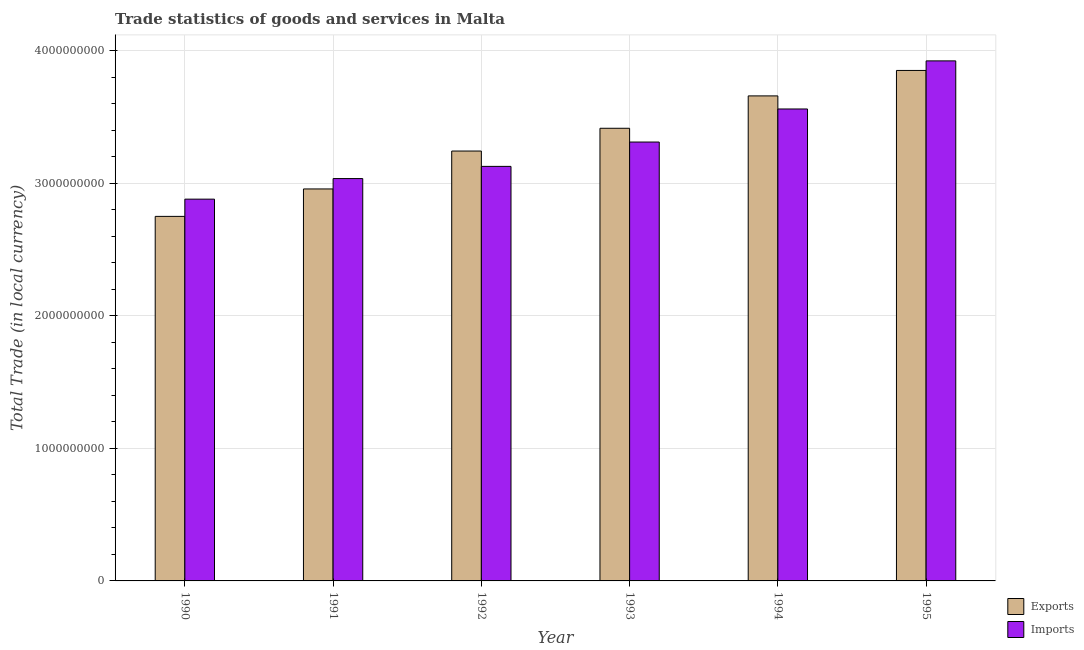How many different coloured bars are there?
Your answer should be compact. 2. How many groups of bars are there?
Your response must be concise. 6. How many bars are there on the 5th tick from the left?
Offer a very short reply. 2. How many bars are there on the 6th tick from the right?
Make the answer very short. 2. What is the label of the 6th group of bars from the left?
Offer a terse response. 1995. What is the export of goods and services in 1992?
Your answer should be very brief. 3.24e+09. Across all years, what is the maximum export of goods and services?
Keep it short and to the point. 3.85e+09. Across all years, what is the minimum imports of goods and services?
Your response must be concise. 2.88e+09. In which year was the export of goods and services minimum?
Keep it short and to the point. 1990. What is the total imports of goods and services in the graph?
Offer a very short reply. 1.98e+1. What is the difference between the export of goods and services in 1990 and that in 1992?
Ensure brevity in your answer.  -4.93e+08. What is the difference between the export of goods and services in 1992 and the imports of goods and services in 1993?
Your answer should be compact. -1.72e+08. What is the average export of goods and services per year?
Provide a short and direct response. 3.31e+09. In how many years, is the imports of goods and services greater than 200000000 LCU?
Give a very brief answer. 6. What is the ratio of the imports of goods and services in 1992 to that in 1994?
Keep it short and to the point. 0.88. What is the difference between the highest and the second highest imports of goods and services?
Provide a succinct answer. 3.63e+08. What is the difference between the highest and the lowest imports of goods and services?
Ensure brevity in your answer.  1.04e+09. What does the 2nd bar from the left in 1992 represents?
Your answer should be compact. Imports. What does the 1st bar from the right in 1990 represents?
Provide a short and direct response. Imports. Are all the bars in the graph horizontal?
Keep it short and to the point. No. How many years are there in the graph?
Provide a short and direct response. 6. Are the values on the major ticks of Y-axis written in scientific E-notation?
Offer a very short reply. No. Does the graph contain any zero values?
Your answer should be very brief. No. Where does the legend appear in the graph?
Give a very brief answer. Bottom right. How many legend labels are there?
Offer a very short reply. 2. How are the legend labels stacked?
Provide a short and direct response. Vertical. What is the title of the graph?
Make the answer very short. Trade statistics of goods and services in Malta. Does "Non-resident workers" appear as one of the legend labels in the graph?
Offer a very short reply. No. What is the label or title of the Y-axis?
Offer a terse response. Total Trade (in local currency). What is the Total Trade (in local currency) of Exports in 1990?
Provide a succinct answer. 2.75e+09. What is the Total Trade (in local currency) in Imports in 1990?
Offer a terse response. 2.88e+09. What is the Total Trade (in local currency) in Exports in 1991?
Your response must be concise. 2.96e+09. What is the Total Trade (in local currency) in Imports in 1991?
Your answer should be compact. 3.04e+09. What is the Total Trade (in local currency) in Exports in 1992?
Give a very brief answer. 3.24e+09. What is the Total Trade (in local currency) of Imports in 1992?
Offer a very short reply. 3.13e+09. What is the Total Trade (in local currency) of Exports in 1993?
Offer a very short reply. 3.42e+09. What is the Total Trade (in local currency) in Imports in 1993?
Keep it short and to the point. 3.31e+09. What is the Total Trade (in local currency) in Exports in 1994?
Ensure brevity in your answer.  3.66e+09. What is the Total Trade (in local currency) of Imports in 1994?
Provide a short and direct response. 3.56e+09. What is the Total Trade (in local currency) of Exports in 1995?
Your answer should be compact. 3.85e+09. What is the Total Trade (in local currency) of Imports in 1995?
Offer a terse response. 3.92e+09. Across all years, what is the maximum Total Trade (in local currency) of Exports?
Provide a short and direct response. 3.85e+09. Across all years, what is the maximum Total Trade (in local currency) in Imports?
Provide a short and direct response. 3.92e+09. Across all years, what is the minimum Total Trade (in local currency) of Exports?
Your answer should be compact. 2.75e+09. Across all years, what is the minimum Total Trade (in local currency) of Imports?
Make the answer very short. 2.88e+09. What is the total Total Trade (in local currency) of Exports in the graph?
Your answer should be compact. 1.99e+1. What is the total Total Trade (in local currency) in Imports in the graph?
Your answer should be very brief. 1.98e+1. What is the difference between the Total Trade (in local currency) of Exports in 1990 and that in 1991?
Offer a terse response. -2.07e+08. What is the difference between the Total Trade (in local currency) in Imports in 1990 and that in 1991?
Provide a short and direct response. -1.55e+08. What is the difference between the Total Trade (in local currency) in Exports in 1990 and that in 1992?
Your response must be concise. -4.93e+08. What is the difference between the Total Trade (in local currency) in Imports in 1990 and that in 1992?
Your answer should be very brief. -2.47e+08. What is the difference between the Total Trade (in local currency) of Exports in 1990 and that in 1993?
Your answer should be very brief. -6.65e+08. What is the difference between the Total Trade (in local currency) of Imports in 1990 and that in 1993?
Make the answer very short. -4.31e+08. What is the difference between the Total Trade (in local currency) of Exports in 1990 and that in 1994?
Your response must be concise. -9.09e+08. What is the difference between the Total Trade (in local currency) in Imports in 1990 and that in 1994?
Ensure brevity in your answer.  -6.81e+08. What is the difference between the Total Trade (in local currency) of Exports in 1990 and that in 1995?
Provide a short and direct response. -1.10e+09. What is the difference between the Total Trade (in local currency) in Imports in 1990 and that in 1995?
Offer a terse response. -1.04e+09. What is the difference between the Total Trade (in local currency) in Exports in 1991 and that in 1992?
Give a very brief answer. -2.86e+08. What is the difference between the Total Trade (in local currency) in Imports in 1991 and that in 1992?
Your response must be concise. -9.19e+07. What is the difference between the Total Trade (in local currency) in Exports in 1991 and that in 1993?
Your answer should be compact. -4.58e+08. What is the difference between the Total Trade (in local currency) in Imports in 1991 and that in 1993?
Offer a terse response. -2.76e+08. What is the difference between the Total Trade (in local currency) in Exports in 1991 and that in 1994?
Your answer should be very brief. -7.02e+08. What is the difference between the Total Trade (in local currency) in Imports in 1991 and that in 1994?
Offer a very short reply. -5.25e+08. What is the difference between the Total Trade (in local currency) in Exports in 1991 and that in 1995?
Provide a short and direct response. -8.94e+08. What is the difference between the Total Trade (in local currency) of Imports in 1991 and that in 1995?
Ensure brevity in your answer.  -8.88e+08. What is the difference between the Total Trade (in local currency) in Exports in 1992 and that in 1993?
Give a very brief answer. -1.72e+08. What is the difference between the Total Trade (in local currency) in Imports in 1992 and that in 1993?
Provide a short and direct response. -1.84e+08. What is the difference between the Total Trade (in local currency) in Exports in 1992 and that in 1994?
Your answer should be compact. -4.16e+08. What is the difference between the Total Trade (in local currency) in Imports in 1992 and that in 1994?
Give a very brief answer. -4.33e+08. What is the difference between the Total Trade (in local currency) of Exports in 1992 and that in 1995?
Make the answer very short. -6.08e+08. What is the difference between the Total Trade (in local currency) in Imports in 1992 and that in 1995?
Make the answer very short. -7.96e+08. What is the difference between the Total Trade (in local currency) of Exports in 1993 and that in 1994?
Provide a succinct answer. -2.44e+08. What is the difference between the Total Trade (in local currency) in Imports in 1993 and that in 1994?
Provide a short and direct response. -2.50e+08. What is the difference between the Total Trade (in local currency) of Exports in 1993 and that in 1995?
Keep it short and to the point. -4.36e+08. What is the difference between the Total Trade (in local currency) in Imports in 1993 and that in 1995?
Ensure brevity in your answer.  -6.13e+08. What is the difference between the Total Trade (in local currency) of Exports in 1994 and that in 1995?
Your answer should be compact. -1.92e+08. What is the difference between the Total Trade (in local currency) in Imports in 1994 and that in 1995?
Keep it short and to the point. -3.63e+08. What is the difference between the Total Trade (in local currency) in Exports in 1990 and the Total Trade (in local currency) in Imports in 1991?
Provide a short and direct response. -2.85e+08. What is the difference between the Total Trade (in local currency) in Exports in 1990 and the Total Trade (in local currency) in Imports in 1992?
Offer a terse response. -3.77e+08. What is the difference between the Total Trade (in local currency) in Exports in 1990 and the Total Trade (in local currency) in Imports in 1993?
Your answer should be compact. -5.61e+08. What is the difference between the Total Trade (in local currency) of Exports in 1990 and the Total Trade (in local currency) of Imports in 1994?
Your answer should be very brief. -8.11e+08. What is the difference between the Total Trade (in local currency) in Exports in 1990 and the Total Trade (in local currency) in Imports in 1995?
Provide a short and direct response. -1.17e+09. What is the difference between the Total Trade (in local currency) of Exports in 1991 and the Total Trade (in local currency) of Imports in 1992?
Ensure brevity in your answer.  -1.70e+08. What is the difference between the Total Trade (in local currency) in Exports in 1991 and the Total Trade (in local currency) in Imports in 1993?
Provide a short and direct response. -3.54e+08. What is the difference between the Total Trade (in local currency) of Exports in 1991 and the Total Trade (in local currency) of Imports in 1994?
Offer a very short reply. -6.04e+08. What is the difference between the Total Trade (in local currency) in Exports in 1991 and the Total Trade (in local currency) in Imports in 1995?
Your answer should be very brief. -9.67e+08. What is the difference between the Total Trade (in local currency) in Exports in 1992 and the Total Trade (in local currency) in Imports in 1993?
Your answer should be very brief. -6.80e+07. What is the difference between the Total Trade (in local currency) in Exports in 1992 and the Total Trade (in local currency) in Imports in 1994?
Provide a short and direct response. -3.18e+08. What is the difference between the Total Trade (in local currency) of Exports in 1992 and the Total Trade (in local currency) of Imports in 1995?
Your response must be concise. -6.81e+08. What is the difference between the Total Trade (in local currency) in Exports in 1993 and the Total Trade (in local currency) in Imports in 1994?
Provide a succinct answer. -1.46e+08. What is the difference between the Total Trade (in local currency) in Exports in 1993 and the Total Trade (in local currency) in Imports in 1995?
Make the answer very short. -5.09e+08. What is the difference between the Total Trade (in local currency) of Exports in 1994 and the Total Trade (in local currency) of Imports in 1995?
Offer a very short reply. -2.64e+08. What is the average Total Trade (in local currency) in Exports per year?
Your answer should be very brief. 3.31e+09. What is the average Total Trade (in local currency) in Imports per year?
Provide a short and direct response. 3.31e+09. In the year 1990, what is the difference between the Total Trade (in local currency) in Exports and Total Trade (in local currency) in Imports?
Ensure brevity in your answer.  -1.30e+08. In the year 1991, what is the difference between the Total Trade (in local currency) in Exports and Total Trade (in local currency) in Imports?
Offer a very short reply. -7.83e+07. In the year 1992, what is the difference between the Total Trade (in local currency) in Exports and Total Trade (in local currency) in Imports?
Provide a short and direct response. 1.16e+08. In the year 1993, what is the difference between the Total Trade (in local currency) of Exports and Total Trade (in local currency) of Imports?
Your answer should be compact. 1.04e+08. In the year 1994, what is the difference between the Total Trade (in local currency) of Exports and Total Trade (in local currency) of Imports?
Make the answer very short. 9.87e+07. In the year 1995, what is the difference between the Total Trade (in local currency) of Exports and Total Trade (in local currency) of Imports?
Provide a succinct answer. -7.22e+07. What is the ratio of the Total Trade (in local currency) in Imports in 1990 to that in 1991?
Give a very brief answer. 0.95. What is the ratio of the Total Trade (in local currency) in Exports in 1990 to that in 1992?
Provide a short and direct response. 0.85. What is the ratio of the Total Trade (in local currency) in Imports in 1990 to that in 1992?
Your answer should be compact. 0.92. What is the ratio of the Total Trade (in local currency) in Exports in 1990 to that in 1993?
Your answer should be compact. 0.81. What is the ratio of the Total Trade (in local currency) of Imports in 1990 to that in 1993?
Ensure brevity in your answer.  0.87. What is the ratio of the Total Trade (in local currency) of Exports in 1990 to that in 1994?
Your answer should be compact. 0.75. What is the ratio of the Total Trade (in local currency) in Imports in 1990 to that in 1994?
Your answer should be compact. 0.81. What is the ratio of the Total Trade (in local currency) of Exports in 1990 to that in 1995?
Ensure brevity in your answer.  0.71. What is the ratio of the Total Trade (in local currency) in Imports in 1990 to that in 1995?
Ensure brevity in your answer.  0.73. What is the ratio of the Total Trade (in local currency) of Exports in 1991 to that in 1992?
Offer a very short reply. 0.91. What is the ratio of the Total Trade (in local currency) in Imports in 1991 to that in 1992?
Make the answer very short. 0.97. What is the ratio of the Total Trade (in local currency) in Exports in 1991 to that in 1993?
Your response must be concise. 0.87. What is the ratio of the Total Trade (in local currency) of Imports in 1991 to that in 1993?
Give a very brief answer. 0.92. What is the ratio of the Total Trade (in local currency) of Exports in 1991 to that in 1994?
Offer a terse response. 0.81. What is the ratio of the Total Trade (in local currency) in Imports in 1991 to that in 1994?
Your answer should be very brief. 0.85. What is the ratio of the Total Trade (in local currency) in Exports in 1991 to that in 1995?
Offer a terse response. 0.77. What is the ratio of the Total Trade (in local currency) of Imports in 1991 to that in 1995?
Provide a short and direct response. 0.77. What is the ratio of the Total Trade (in local currency) in Exports in 1992 to that in 1993?
Give a very brief answer. 0.95. What is the ratio of the Total Trade (in local currency) in Imports in 1992 to that in 1993?
Provide a short and direct response. 0.94. What is the ratio of the Total Trade (in local currency) in Exports in 1992 to that in 1994?
Provide a short and direct response. 0.89. What is the ratio of the Total Trade (in local currency) of Imports in 1992 to that in 1994?
Your answer should be very brief. 0.88. What is the ratio of the Total Trade (in local currency) of Exports in 1992 to that in 1995?
Keep it short and to the point. 0.84. What is the ratio of the Total Trade (in local currency) of Imports in 1992 to that in 1995?
Provide a short and direct response. 0.8. What is the ratio of the Total Trade (in local currency) of Exports in 1993 to that in 1994?
Your answer should be very brief. 0.93. What is the ratio of the Total Trade (in local currency) in Imports in 1993 to that in 1994?
Provide a short and direct response. 0.93. What is the ratio of the Total Trade (in local currency) in Exports in 1993 to that in 1995?
Offer a terse response. 0.89. What is the ratio of the Total Trade (in local currency) of Imports in 1993 to that in 1995?
Provide a succinct answer. 0.84. What is the ratio of the Total Trade (in local currency) of Exports in 1994 to that in 1995?
Your response must be concise. 0.95. What is the ratio of the Total Trade (in local currency) of Imports in 1994 to that in 1995?
Your answer should be very brief. 0.91. What is the difference between the highest and the second highest Total Trade (in local currency) of Exports?
Offer a terse response. 1.92e+08. What is the difference between the highest and the second highest Total Trade (in local currency) of Imports?
Keep it short and to the point. 3.63e+08. What is the difference between the highest and the lowest Total Trade (in local currency) of Exports?
Offer a very short reply. 1.10e+09. What is the difference between the highest and the lowest Total Trade (in local currency) of Imports?
Ensure brevity in your answer.  1.04e+09. 